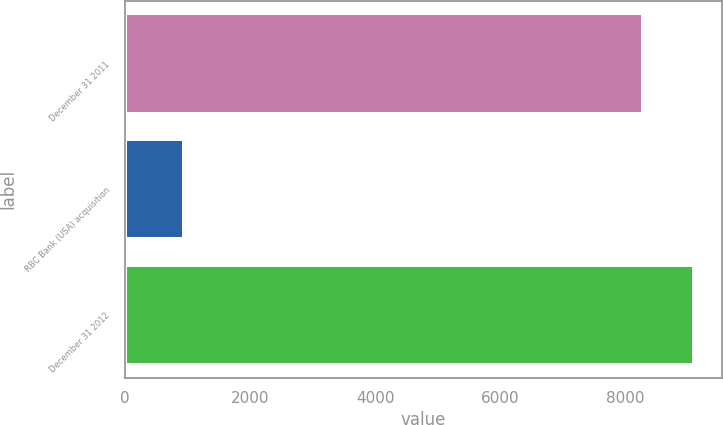<chart> <loc_0><loc_0><loc_500><loc_500><bar_chart><fcel>December 31 2011<fcel>RBC Bank (USA) acquisition<fcel>December 31 2012<nl><fcel>8285<fcel>950<fcel>9097.2<nl></chart> 